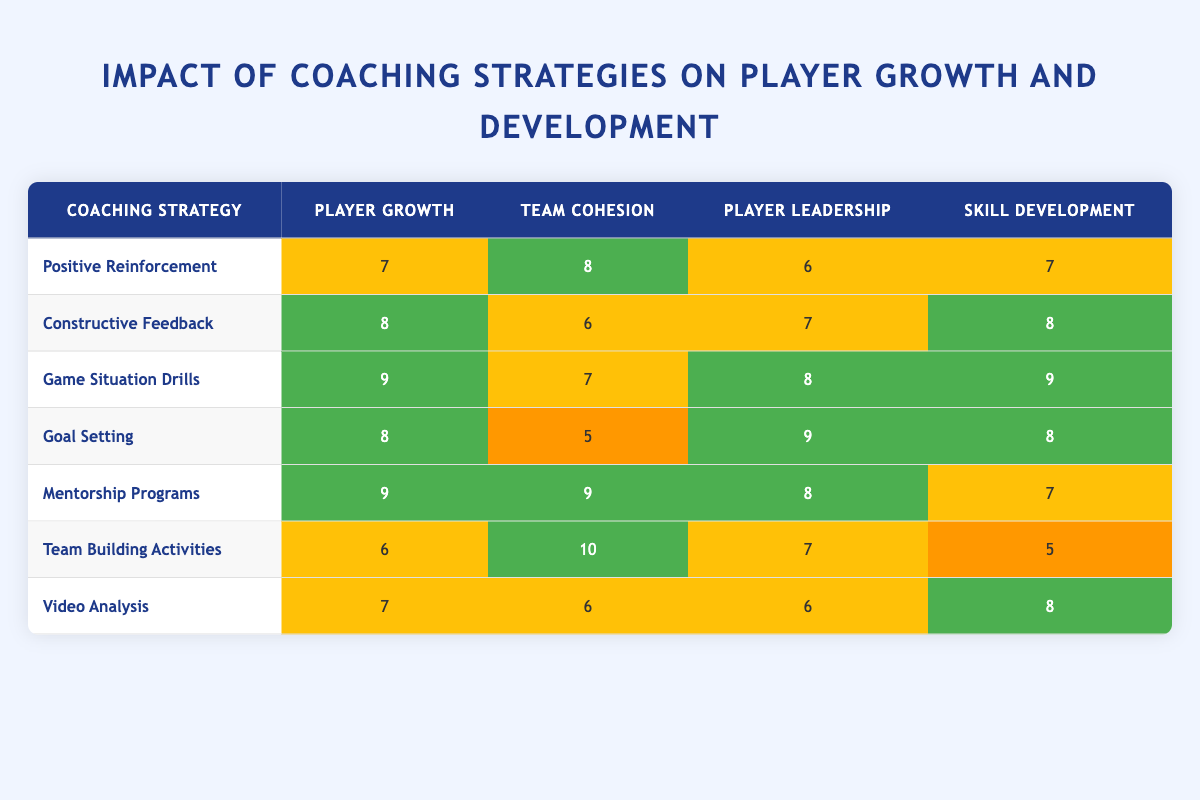What is the player growth rating for the "Game Situation Drills" strategy? The player growth rating is directly listed in the row corresponding to "Game Situation Drills." Looking at that row, the value for player growth is 9.
Answer: 9 Which coaching strategy has the highest team cohesion rating? By examining the team cohesion ratings in the table, the "Team Building Activities" strategy has a rating of 10, which is the highest among all strategies.
Answer: Team Building Activities What is the average player leadership score for all strategies? To find the average player leadership score, first, sum the player leadership values: (6 + 7 + 8 + 9 + 8 + 7 + 6) = 51. There are 7 strategies, so the average is 51/7 = approximately 7.29.
Answer: 7.29 Is there a coaching strategy that has a high player growth rating but low team cohesion? "Goal Setting" has a high player growth rating of 8 but a low team cohesion rating of 5. This fits the criteria of having high player growth and low team cohesion.
Answer: Yes Which strategy has the highest skill development rating, and what is that rating? Looking through the skill development ratings in the table, "Game Situation Drills" has the highest rating of 9. Therefore, my answer is based on that observation.
Answer: Game Situation Drills, 9 What is the difference in player growth ratings between "Mentorship Programs" and "Team Building Activities"? The player growth rating for "Mentorship Programs" is 9, while for "Team Building Activities," it is 6. The difference is calculated as 9 - 6 = 3.
Answer: 3 Does any strategy have a rating of 10 in player growth? Checking all the player growth ratings, none of the strategies listed have a rating of 10; the highest is 9.
Answer: No Which coaching strategy has the best overall ratings across all four categories? By inspecting all the ratings, "Game Situation Drills" stands out as it has the highest ratings in player growth (9), player leadership (8), and skill development (9), only slightly lower in team cohesion (7), making it the best overall.
Answer: Game Situation Drills What is the total score when combining player growth and skill development for the "Constructive Feedback" strategy? For "Constructive Feedback," the player growth score is 8 and the skill development score is 8. Adding these two values gives a total of 8 + 8 = 16.
Answer: 16 